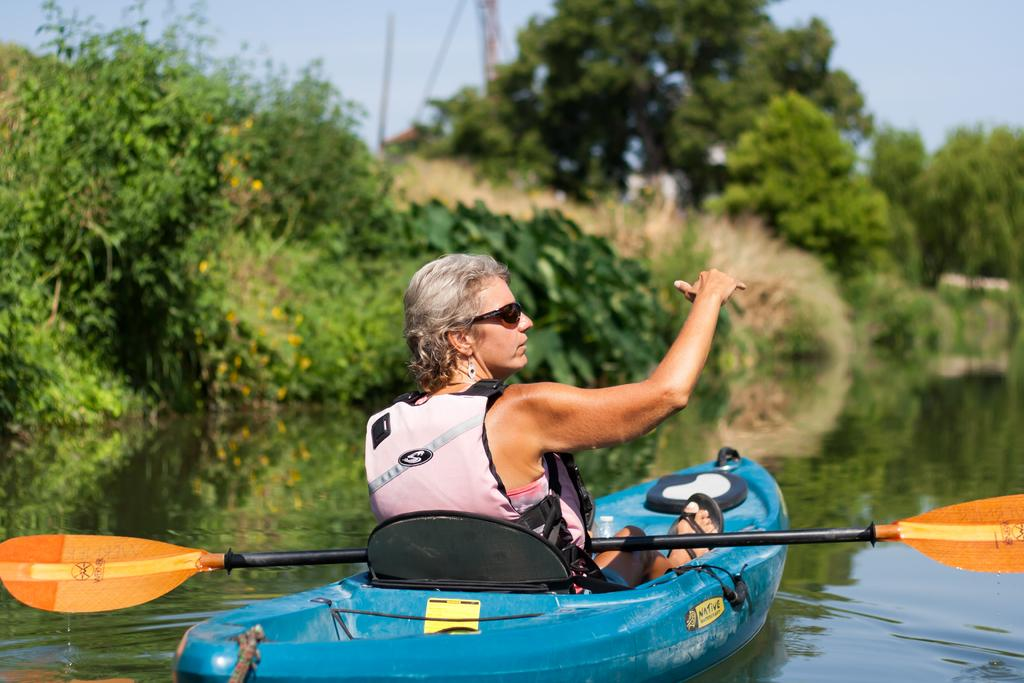What is the lady doing in the image? The lady is sitting on a boat in the image. What is the setting of the image? There is water visible at the bottom of the image, and there are trees and a pole in the background. What is the lady's mode of transportation in the image? The lady is sitting on a boat, which is a mode of transportation on water. What is visible in the sky in the image? The sky is visible in the background of the image. How many oranges are hanging from the pole in the image? There are no oranges present in the image; the pole is in the background of the image without any oranges hanging from it. 